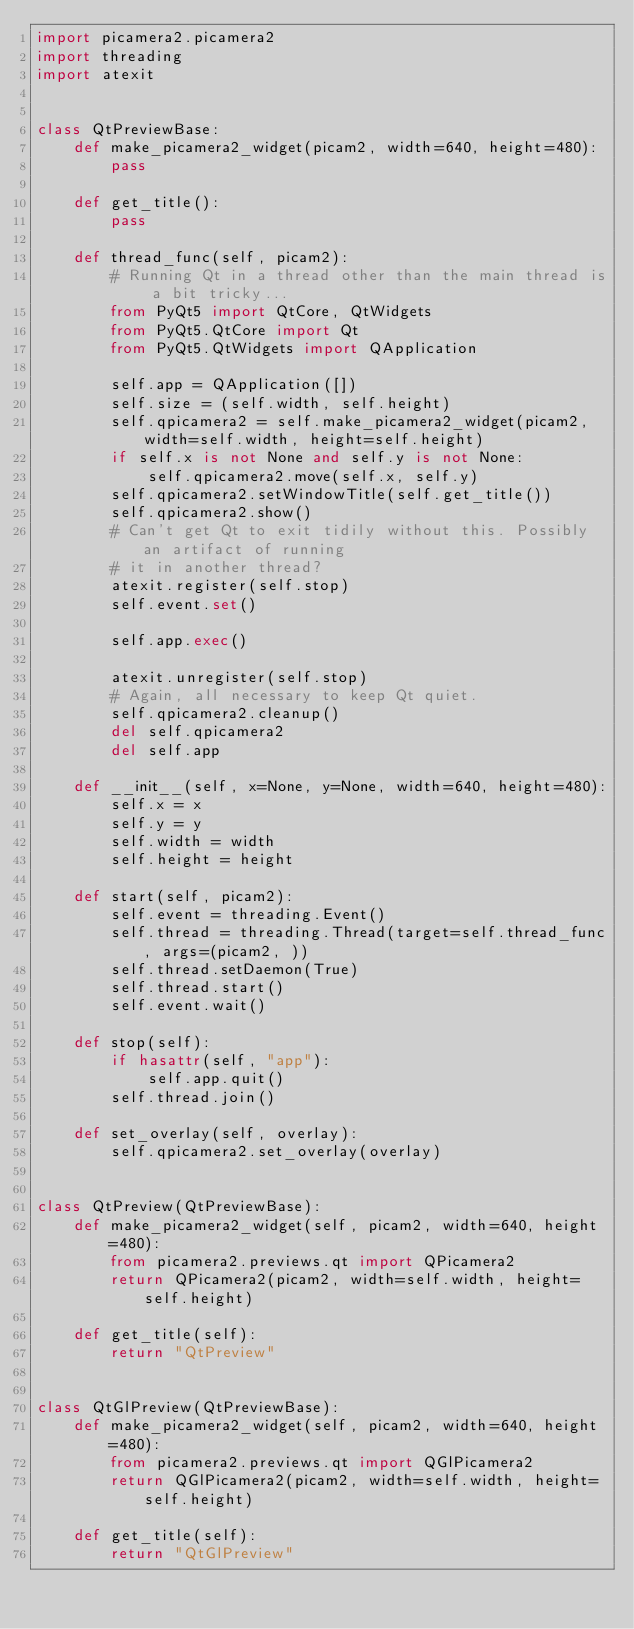<code> <loc_0><loc_0><loc_500><loc_500><_Python_>import picamera2.picamera2
import threading
import atexit


class QtPreviewBase:
    def make_picamera2_widget(picam2, width=640, height=480):
        pass

    def get_title():
        pass

    def thread_func(self, picam2):
        # Running Qt in a thread other than the main thread is a bit tricky...
        from PyQt5 import QtCore, QtWidgets
        from PyQt5.QtCore import Qt
        from PyQt5.QtWidgets import QApplication

        self.app = QApplication([])
        self.size = (self.width, self.height)
        self.qpicamera2 = self.make_picamera2_widget(picam2, width=self.width, height=self.height)
        if self.x is not None and self.y is not None:
            self.qpicamera2.move(self.x, self.y)
        self.qpicamera2.setWindowTitle(self.get_title())
        self.qpicamera2.show()
        # Can't get Qt to exit tidily without this. Possibly an artifact of running
        # it in another thread?
        atexit.register(self.stop)
        self.event.set()

        self.app.exec()

        atexit.unregister(self.stop)
        # Again, all necessary to keep Qt quiet.
        self.qpicamera2.cleanup()
        del self.qpicamera2
        del self.app

    def __init__(self, x=None, y=None, width=640, height=480):
        self.x = x
        self.y = y
        self.width = width
        self.height = height

    def start(self, picam2):
        self.event = threading.Event()
        self.thread = threading.Thread(target=self.thread_func, args=(picam2, ))
        self.thread.setDaemon(True)
        self.thread.start()
        self.event.wait()

    def stop(self):
        if hasattr(self, "app"):
            self.app.quit()
        self.thread.join()

    def set_overlay(self, overlay):
        self.qpicamera2.set_overlay(overlay)


class QtPreview(QtPreviewBase):
    def make_picamera2_widget(self, picam2, width=640, height=480):
        from picamera2.previews.qt import QPicamera2
        return QPicamera2(picam2, width=self.width, height=self.height)

    def get_title(self):
        return "QtPreview"


class QtGlPreview(QtPreviewBase):
    def make_picamera2_widget(self, picam2, width=640, height=480):
        from picamera2.previews.qt import QGlPicamera2
        return QGlPicamera2(picam2, width=self.width, height=self.height)

    def get_title(self):
        return "QtGlPreview"
</code> 